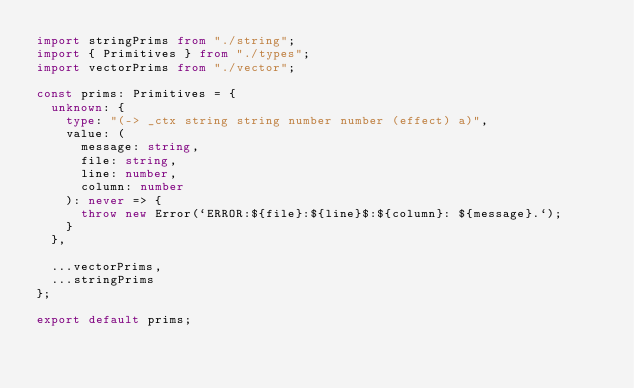<code> <loc_0><loc_0><loc_500><loc_500><_TypeScript_>import stringPrims from "./string";
import { Primitives } from "./types";
import vectorPrims from "./vector";

const prims: Primitives = {
  unknown: {
    type: "(-> _ctx string string number number (effect) a)",
    value: (
      message: string,
      file: string,
      line: number,
      column: number
    ): never => {
      throw new Error(`ERROR:${file}:${line}$:${column}: ${message}.`);
    }
  },

  ...vectorPrims,
  ...stringPrims
};

export default prims;
</code> 